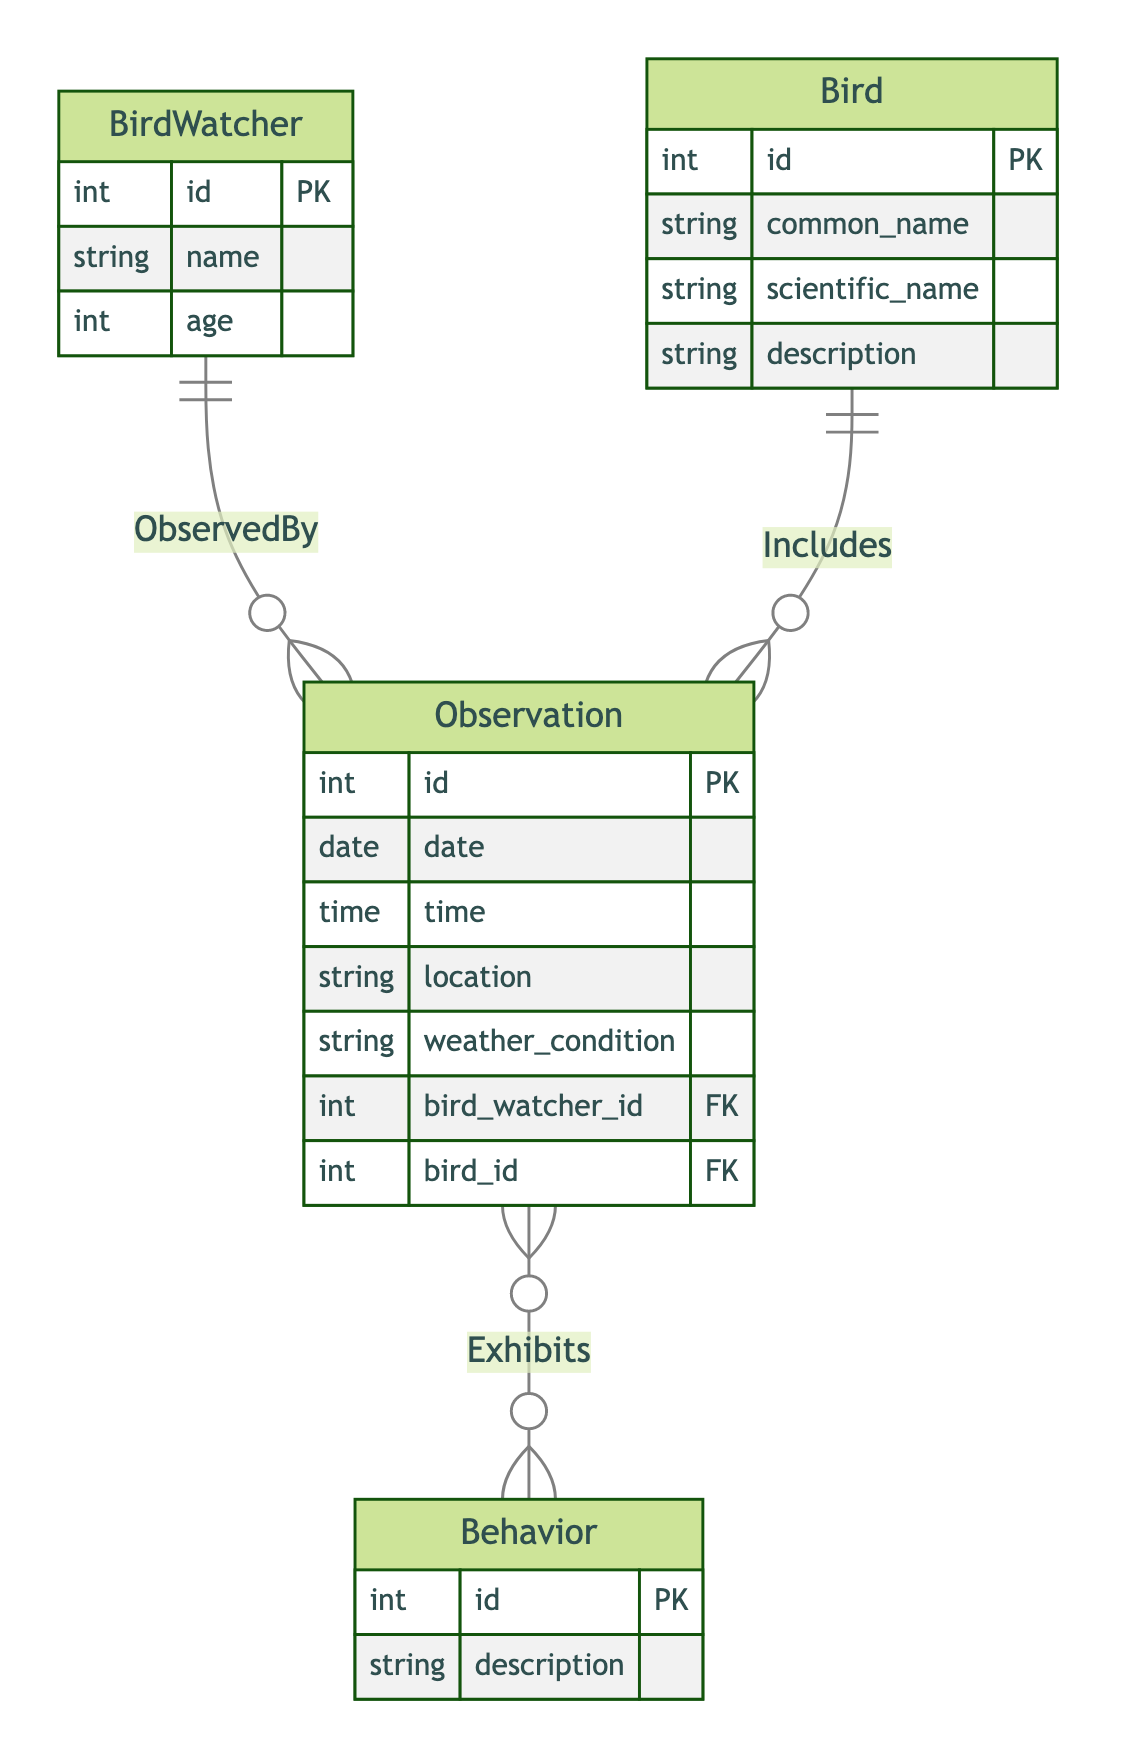What's the primary key of the BirdWatcher entity? The primary key of the BirdWatcher entity is "id," which uniquely identifies each BirdWatcher in the database.
Answer: id How many attributes does the Bird entity have? The Bird entity has four attributes: id, common_name, scientific_name, and description.
Answer: four What is the relationship between Observation and BirdWatcher? The relationship is defined as "ObservedBy," indicating that many Observations can be linked to one BirdWatcher. This is a many-to-one relationship.
Answer: ObservedBy How many entities are depicted in this diagram? The diagram includes four entities: BirdWatcher, Bird, Observation, and Behavior.
Answer: four Which entity includes the foreign key "bird_watcher_id"? The Observation entity includes the foreign key "bird_watcher_id," which establishes a relationship with the BirdWatcher entity.
Answer: Observation What is the cardinality of the relationship between Observation and Behavior? The cardinality between Observation and Behavior is many-to-many, indicating that each Observation can exhibit multiple Behaviors and each Behavior can be exhibited in multiple Observations.
Answer: many-to-many What attribute must be present in the Observation entity to show the date of observation? The attribute that must be present in the Observation entity to indicate the date is "date."
Answer: date Which entity does the "Includes" relationship connect? The "Includes" relationship connects the Observation entity with the Bird entity, showing that an Observation can include one Bird.
Answer: Bird Which entity has the description attribute? The Behavior entity has the description attribute, which describes different behaviors exhibited by birds during observations.
Answer: Behavior 